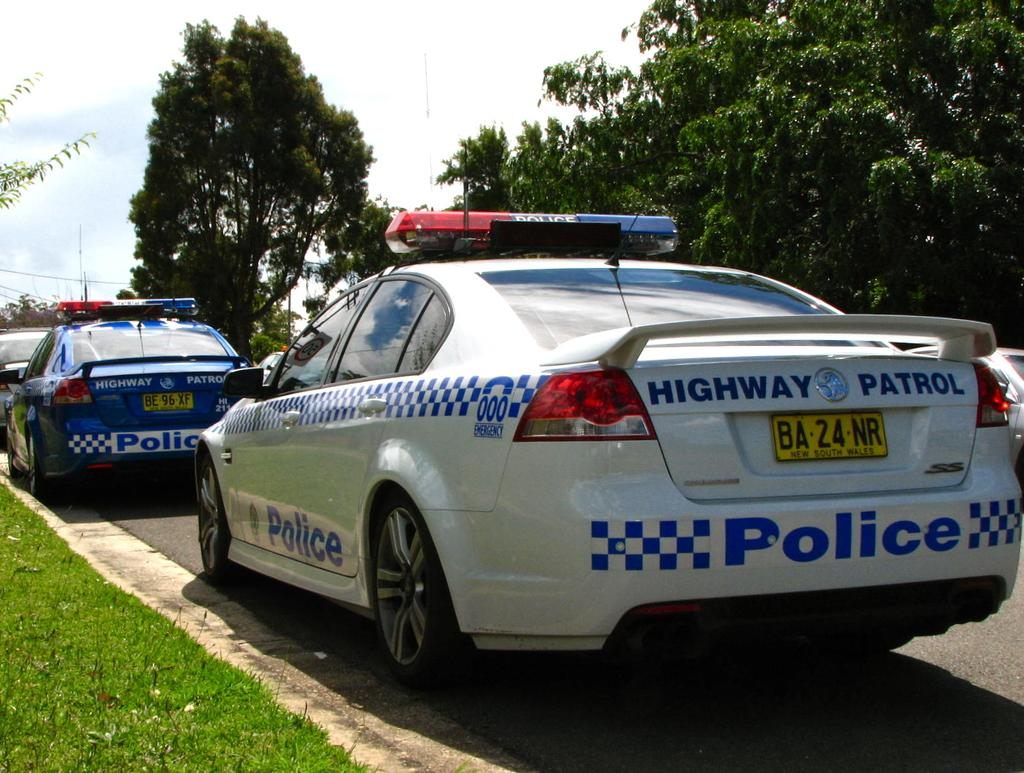What can be seen in the image? There are vehicles in the image. Can you describe one of the vehicles? One vehicle is white and blue in color. What is visible in the background of the image? There are trees in the background of the image. What is the color of the trees? The trees are green in color. What else is visible in the image? The sky is visible in the image. What is the color of the sky? The sky is white in color. How many pipes are visible in the image? There are no pipes present in the image. What type of pipe is located in the middle of the image? There is no pipe in the image, so it cannot be determined if there is one in the middle or not. 